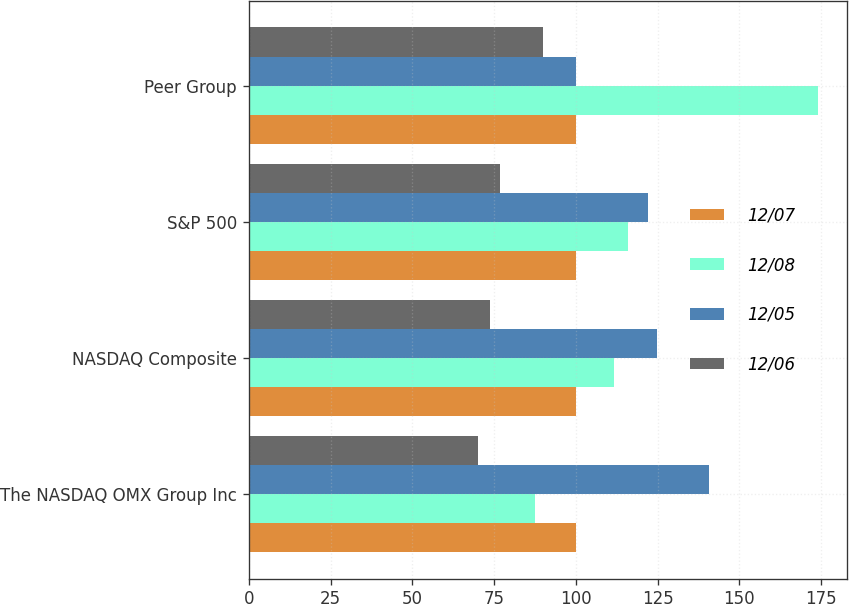Convert chart. <chart><loc_0><loc_0><loc_500><loc_500><stacked_bar_chart><ecel><fcel>The NASDAQ OMX Group Inc<fcel>NASDAQ Composite<fcel>S&P 500<fcel>Peer Group<nl><fcel>12/07<fcel>100<fcel>100<fcel>100<fcel>100<nl><fcel>12/08<fcel>87.52<fcel>111.74<fcel>115.8<fcel>174.16<nl><fcel>12/05<fcel>140.68<fcel>124.67<fcel>122.16<fcel>100<nl><fcel>12/06<fcel>70.24<fcel>73.77<fcel>76.96<fcel>89.99<nl></chart> 